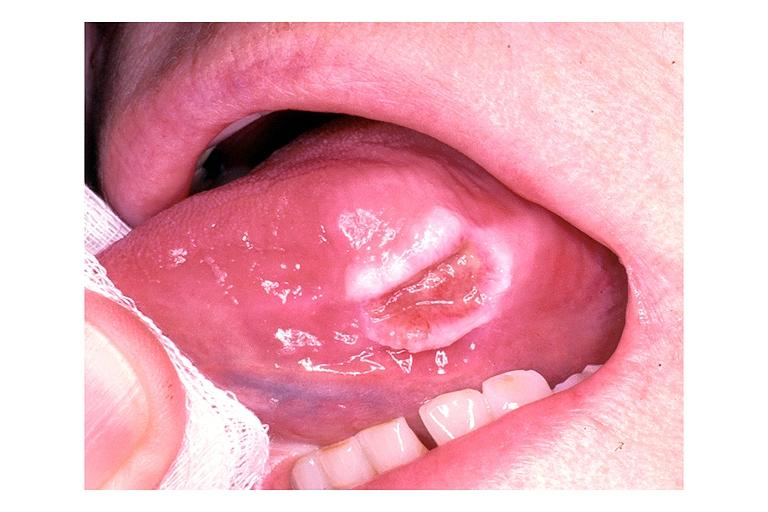s oral present?
Answer the question using a single word or phrase. Yes 